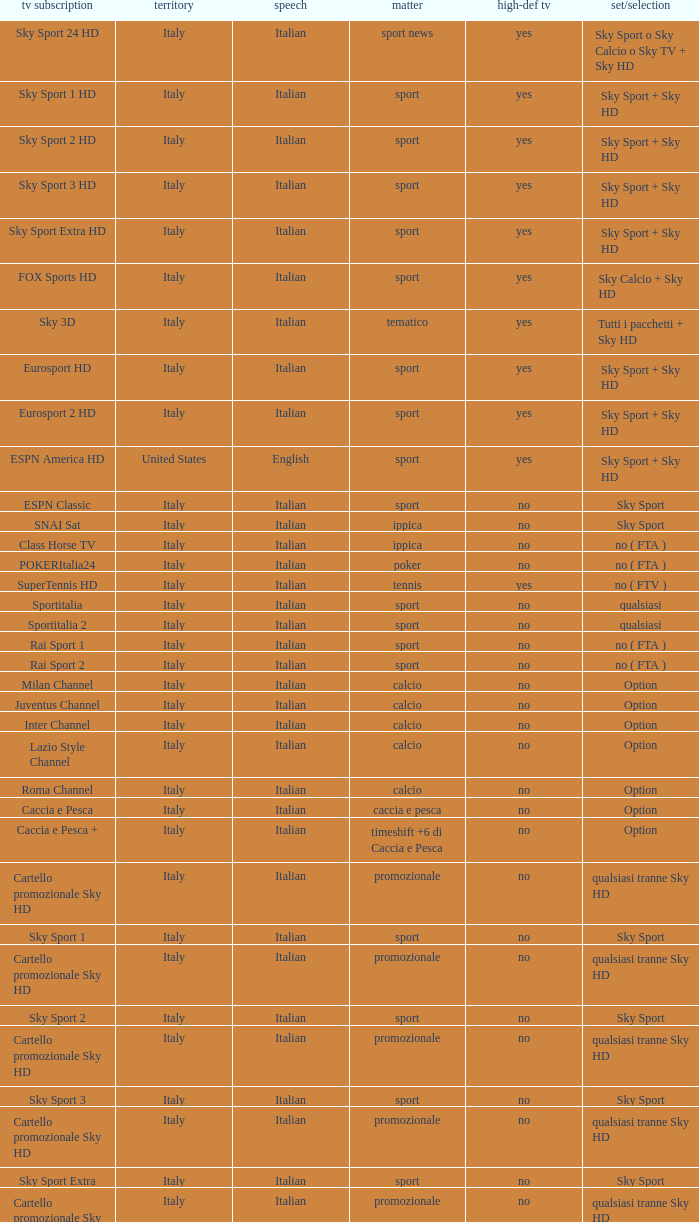What is Television Service, when Content is Calcio, and when Package/Option is Option? Milan Channel, Juventus Channel, Inter Channel, Lazio Style Channel, Roma Channel. 